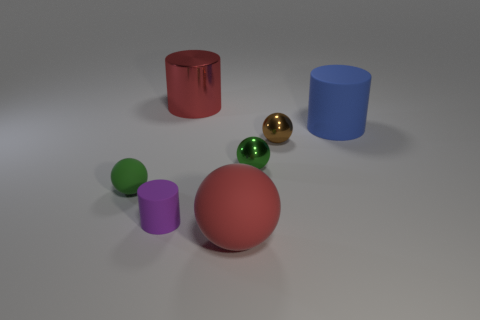Subtract 1 balls. How many balls are left? 3 Add 2 brown shiny cylinders. How many objects exist? 9 Subtract all cylinders. How many objects are left? 4 Add 2 red objects. How many red objects are left? 4 Add 6 big metallic cylinders. How many big metallic cylinders exist? 7 Subtract 0 yellow blocks. How many objects are left? 7 Subtract all tiny green spheres. Subtract all large red matte balls. How many objects are left? 4 